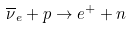Convert formula to latex. <formula><loc_0><loc_0><loc_500><loc_500>\overline { \nu } _ { e } + p \rightarrow e ^ { + } + n</formula> 